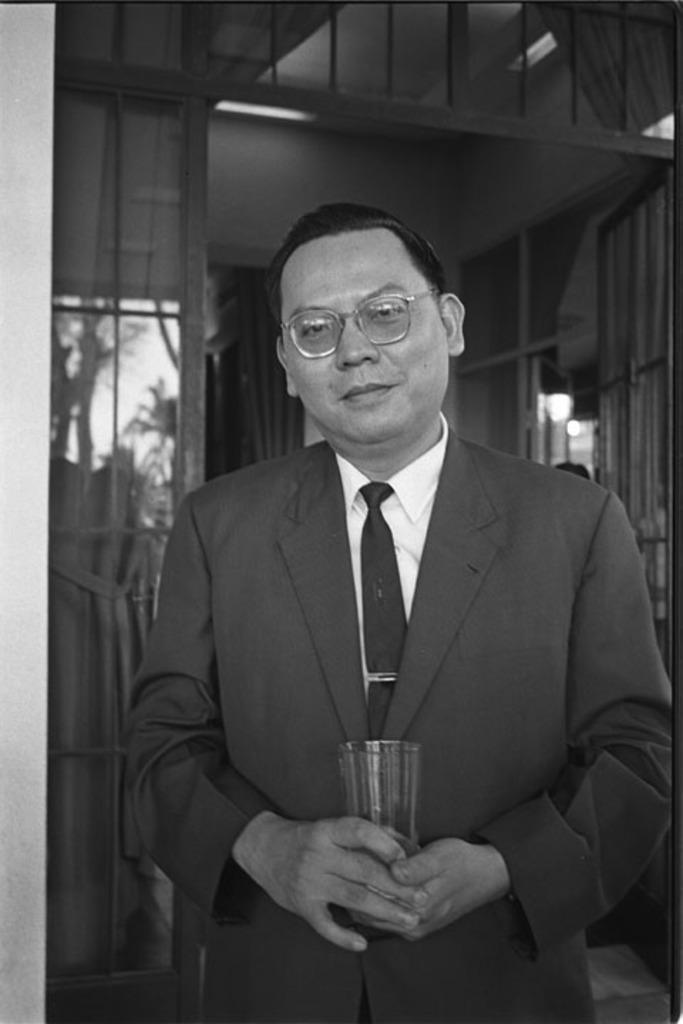Can you describe this image briefly? In this image, in the middle there is a man, he wears a suit, shirt, tie, he is holding a glass. In the background there are light, windows, trees, sky. 